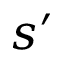Convert formula to latex. <formula><loc_0><loc_0><loc_500><loc_500>s ^ { \prime }</formula> 